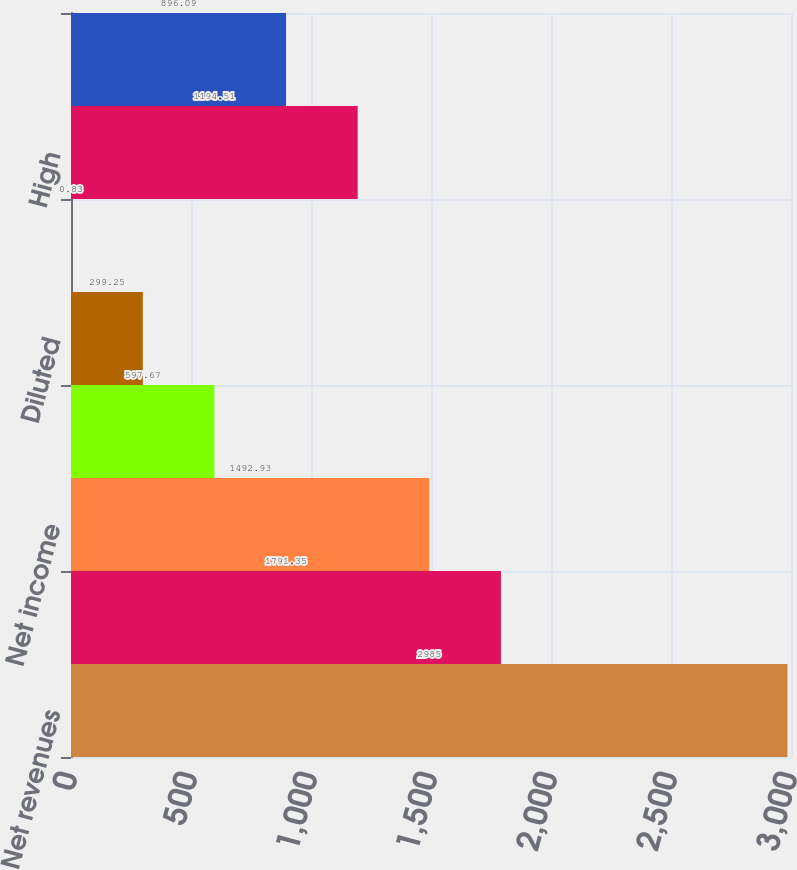<chart> <loc_0><loc_0><loc_500><loc_500><bar_chart><fcel>Net revenues<fcel>Pretax income<fcel>Net income<fcel>Basic<fcel>Diluted<fcel>Cash dividends declared per<fcel>High<fcel>Low<nl><fcel>2985<fcel>1791.35<fcel>1492.93<fcel>597.67<fcel>299.25<fcel>0.83<fcel>1194.51<fcel>896.09<nl></chart> 